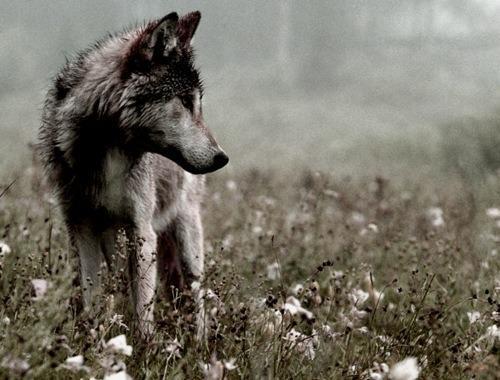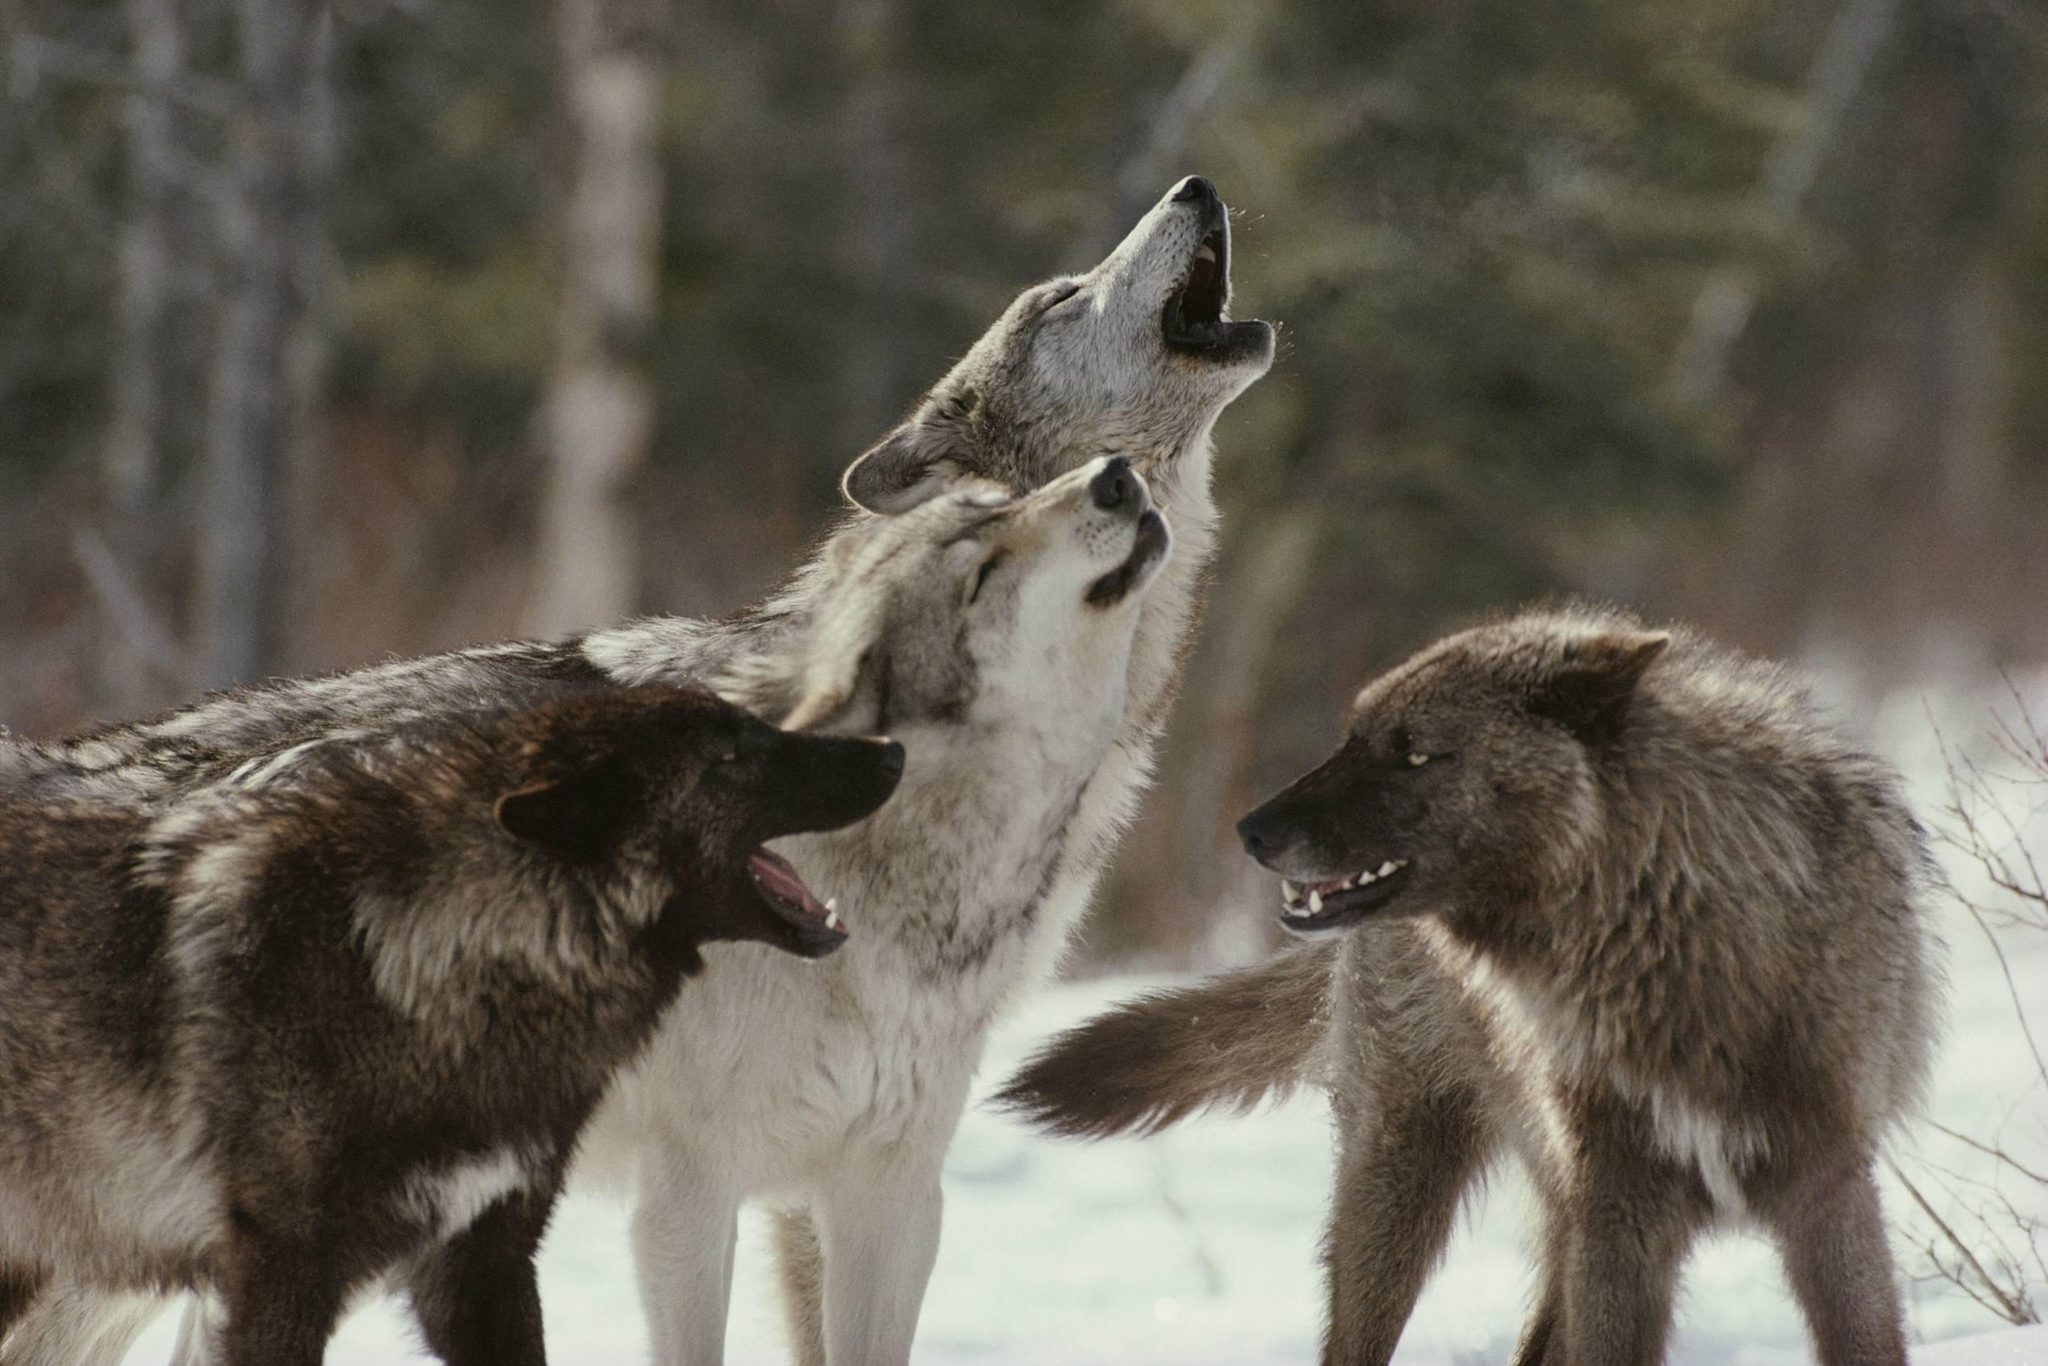The first image is the image on the left, the second image is the image on the right. For the images displayed, is the sentence "The right image includes a rightward-turned wolf with its head and neck raised, eyes closed, and mouth open in a howling pose." factually correct? Answer yes or no. Yes. 